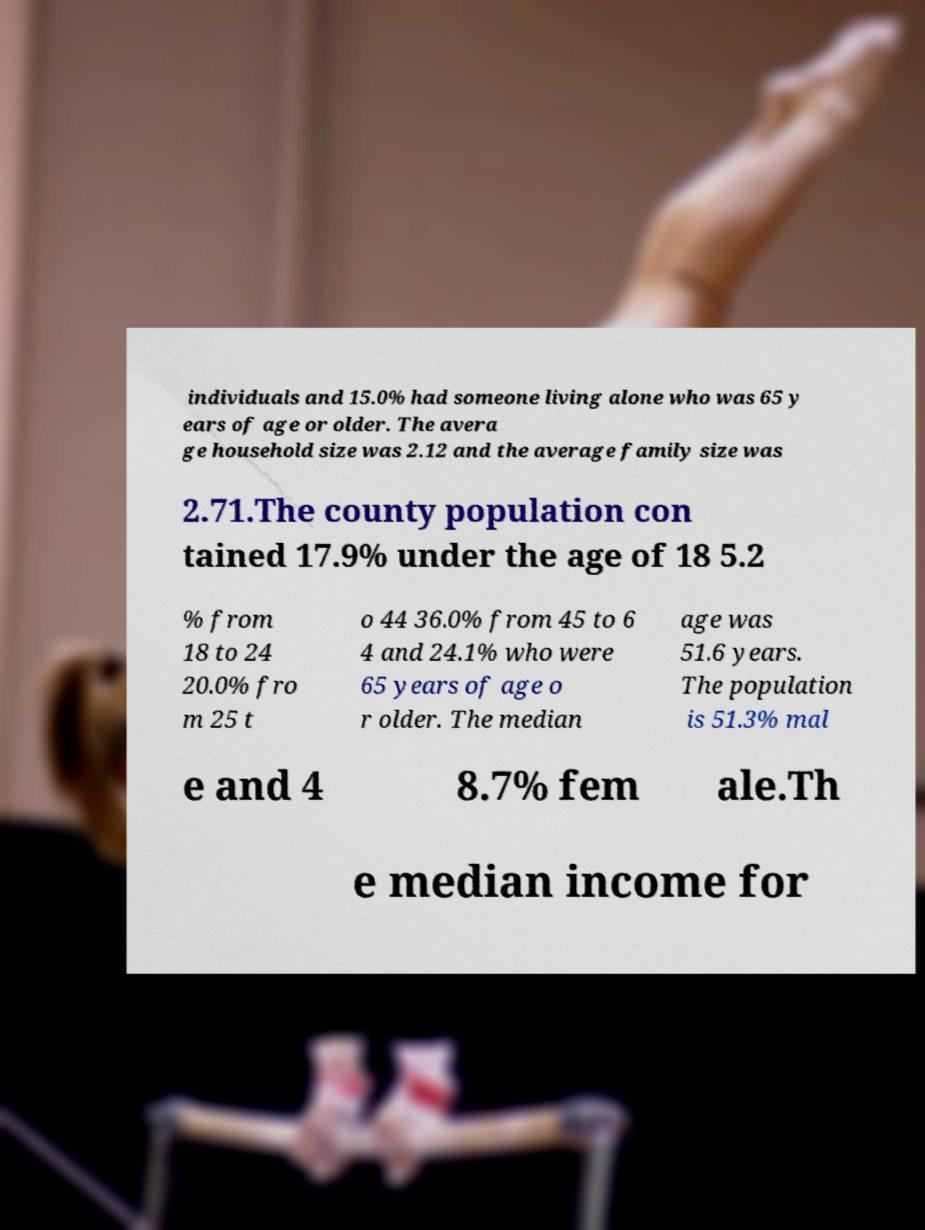What messages or text are displayed in this image? I need them in a readable, typed format. individuals and 15.0% had someone living alone who was 65 y ears of age or older. The avera ge household size was 2.12 and the average family size was 2.71.The county population con tained 17.9% under the age of 18 5.2 % from 18 to 24 20.0% fro m 25 t o 44 36.0% from 45 to 6 4 and 24.1% who were 65 years of age o r older. The median age was 51.6 years. The population is 51.3% mal e and 4 8.7% fem ale.Th e median income for 